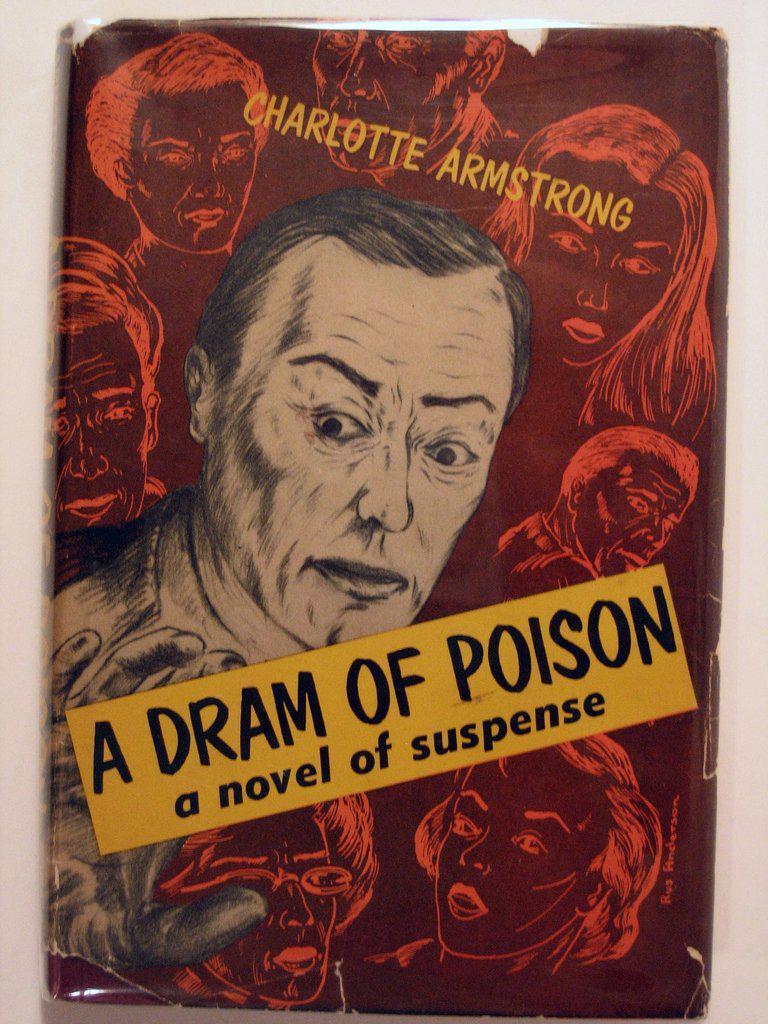Could you give a brief overview of what you see in this image? In this picture we can see a book cover, we can see some faces and some text on this book cover. 